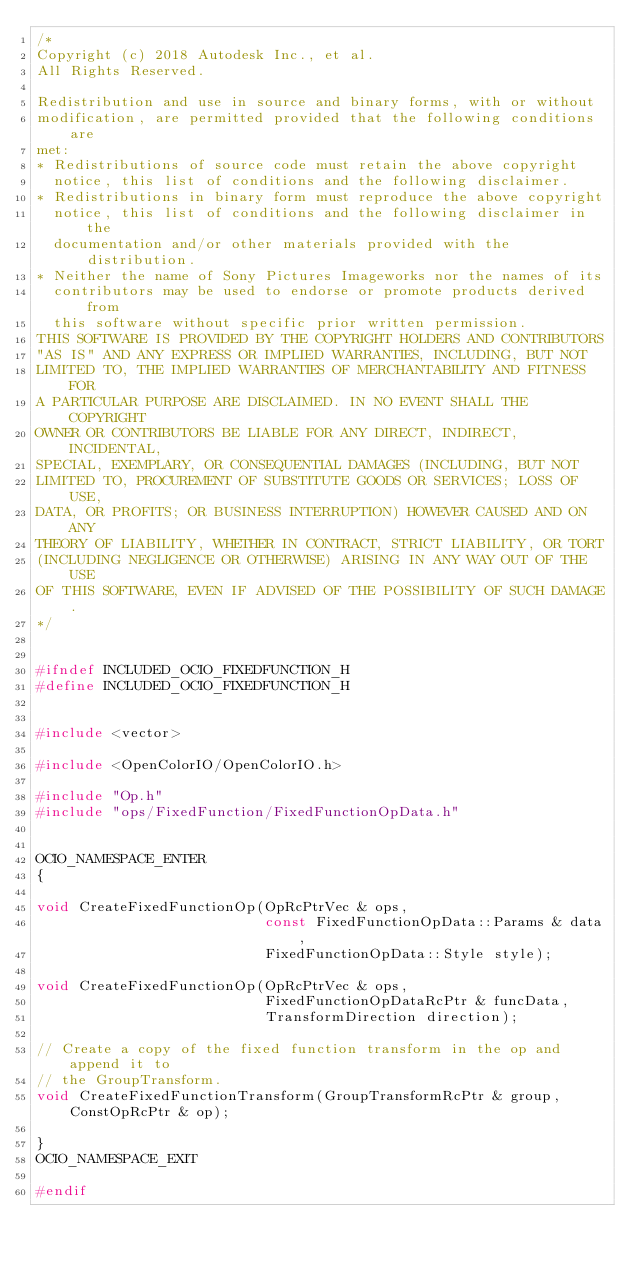Convert code to text. <code><loc_0><loc_0><loc_500><loc_500><_C_>/*
Copyright (c) 2018 Autodesk Inc., et al.
All Rights Reserved.

Redistribution and use in source and binary forms, with or without
modification, are permitted provided that the following conditions are
met:
* Redistributions of source code must retain the above copyright
  notice, this list of conditions and the following disclaimer.
* Redistributions in binary form must reproduce the above copyright
  notice, this list of conditions and the following disclaimer in the
  documentation and/or other materials provided with the distribution.
* Neither the name of Sony Pictures Imageworks nor the names of its
  contributors may be used to endorse or promote products derived from
  this software without specific prior written permission.
THIS SOFTWARE IS PROVIDED BY THE COPYRIGHT HOLDERS AND CONTRIBUTORS
"AS IS" AND ANY EXPRESS OR IMPLIED WARRANTIES, INCLUDING, BUT NOT
LIMITED TO, THE IMPLIED WARRANTIES OF MERCHANTABILITY AND FITNESS FOR
A PARTICULAR PURPOSE ARE DISCLAIMED. IN NO EVENT SHALL THE COPYRIGHT
OWNER OR CONTRIBUTORS BE LIABLE FOR ANY DIRECT, INDIRECT, INCIDENTAL,
SPECIAL, EXEMPLARY, OR CONSEQUENTIAL DAMAGES (INCLUDING, BUT NOT
LIMITED TO, PROCUREMENT OF SUBSTITUTE GOODS OR SERVICES; LOSS OF USE,
DATA, OR PROFITS; OR BUSINESS INTERRUPTION) HOWEVER CAUSED AND ON ANY
THEORY OF LIABILITY, WHETHER IN CONTRACT, STRICT LIABILITY, OR TORT
(INCLUDING NEGLIGENCE OR OTHERWISE) ARISING IN ANY WAY OUT OF THE USE
OF THIS SOFTWARE, EVEN IF ADVISED OF THE POSSIBILITY OF SUCH DAMAGE.
*/


#ifndef INCLUDED_OCIO_FIXEDFUNCTION_H
#define INCLUDED_OCIO_FIXEDFUNCTION_H


#include <vector>

#include <OpenColorIO/OpenColorIO.h>

#include "Op.h"
#include "ops/FixedFunction/FixedFunctionOpData.h"


OCIO_NAMESPACE_ENTER
{

void CreateFixedFunctionOp(OpRcPtrVec & ops, 
                           const FixedFunctionOpData::Params & data,
                           FixedFunctionOpData::Style style);

void CreateFixedFunctionOp(OpRcPtrVec & ops,
                           FixedFunctionOpDataRcPtr & funcData,
                           TransformDirection direction);

// Create a copy of the fixed function transform in the op and append it to
// the GroupTransform.
void CreateFixedFunctionTransform(GroupTransformRcPtr & group, ConstOpRcPtr & op);

}
OCIO_NAMESPACE_EXIT

#endif
</code> 